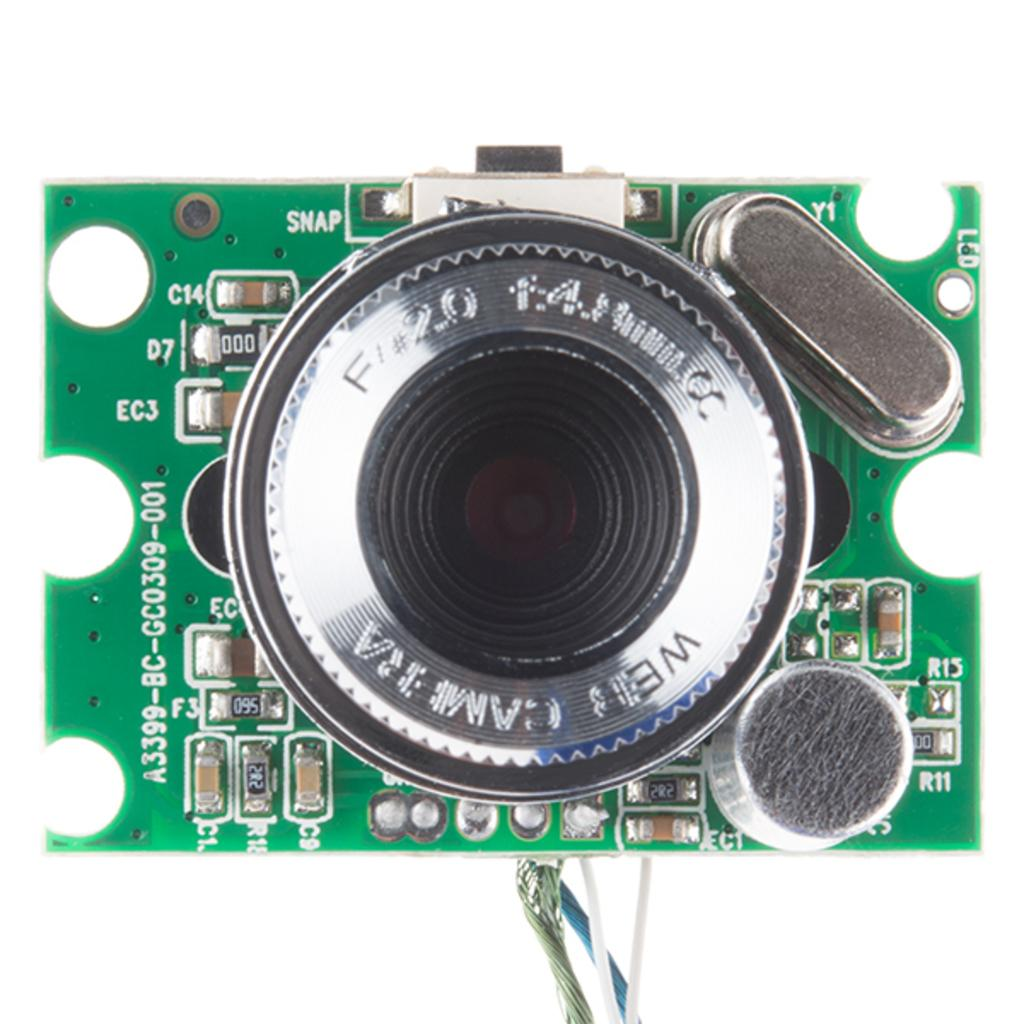What is the main object in the image? There is a chip in the image. What color is the chip? The chip is green in color. Is there any text on the chip? Yes, there is text written on the chip. What else can be seen at the bottom of the image? There are wires at the bottom of the image. Can you see a river flowing in the background of the image? There is no river visible in the image; it features a green chip with text and wires at the bottom. Is there a hat on top of the chip in the image? There is no hat present in the image; it only shows a green chip with text and wires at the bottom. 